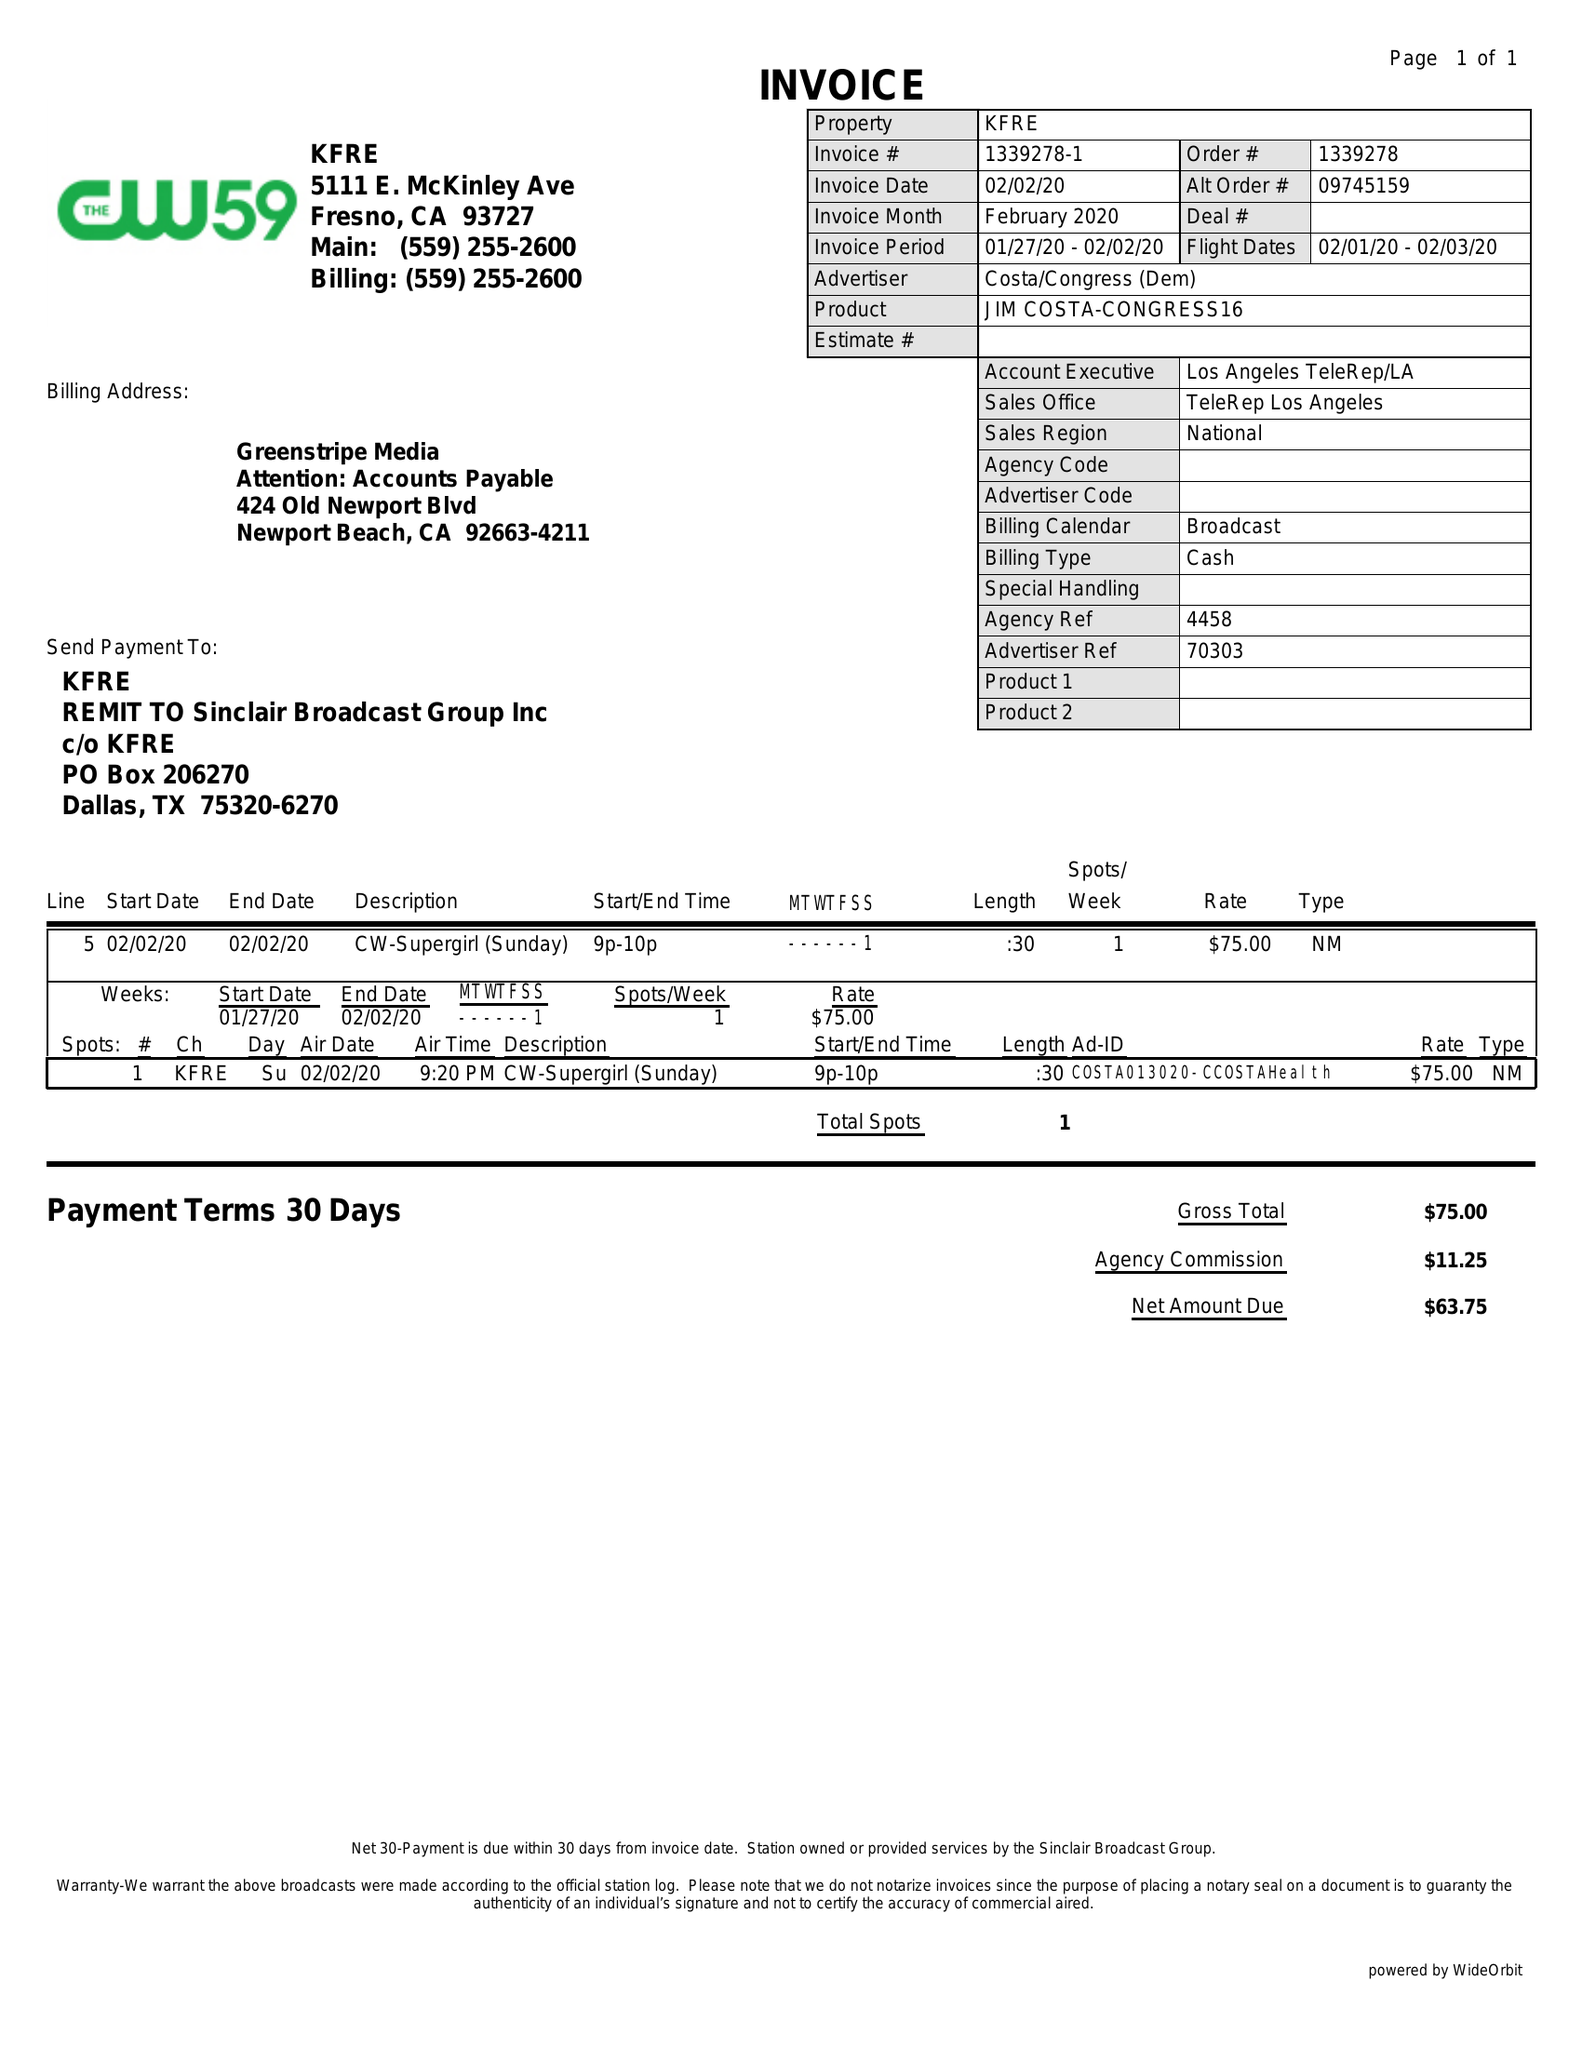What is the value for the flight_to?
Answer the question using a single word or phrase. 02/03/20 